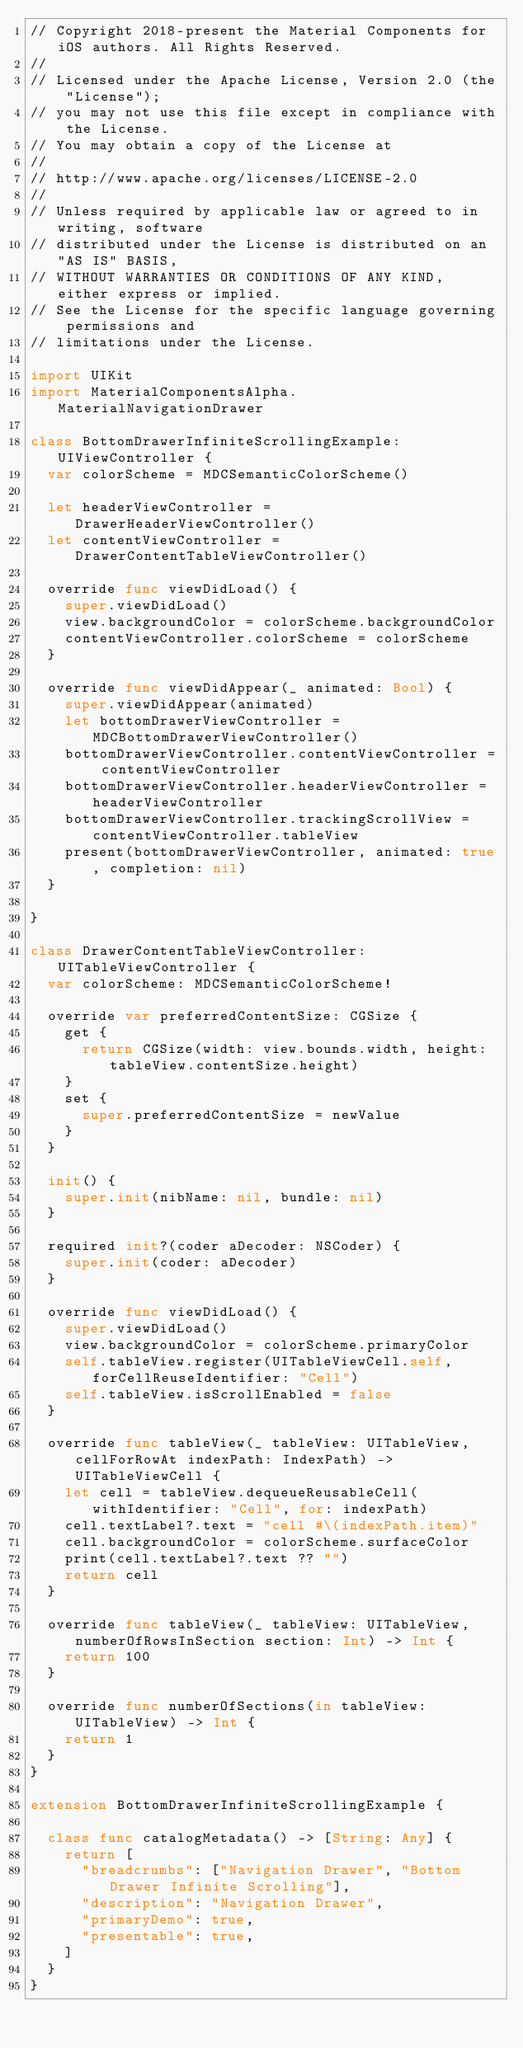Convert code to text. <code><loc_0><loc_0><loc_500><loc_500><_Swift_>// Copyright 2018-present the Material Components for iOS authors. All Rights Reserved.
//
// Licensed under the Apache License, Version 2.0 (the "License");
// you may not use this file except in compliance with the License.
// You may obtain a copy of the License at
//
// http://www.apache.org/licenses/LICENSE-2.0
//
// Unless required by applicable law or agreed to in writing, software
// distributed under the License is distributed on an "AS IS" BASIS,
// WITHOUT WARRANTIES OR CONDITIONS OF ANY KIND, either express or implied.
// See the License for the specific language governing permissions and
// limitations under the License.

import UIKit
import MaterialComponentsAlpha.MaterialNavigationDrawer

class BottomDrawerInfiniteScrollingExample: UIViewController {
  var colorScheme = MDCSemanticColorScheme()

  let headerViewController = DrawerHeaderViewController()
  let contentViewController = DrawerContentTableViewController()

  override func viewDidLoad() {
    super.viewDidLoad()
    view.backgroundColor = colorScheme.backgroundColor
    contentViewController.colorScheme = colorScheme
  }

  override func viewDidAppear(_ animated: Bool) {
    super.viewDidAppear(animated)
    let bottomDrawerViewController = MDCBottomDrawerViewController()
    bottomDrawerViewController.contentViewController = contentViewController
    bottomDrawerViewController.headerViewController = headerViewController
    bottomDrawerViewController.trackingScrollView = contentViewController.tableView
    present(bottomDrawerViewController, animated: true, completion: nil)
  }

}

class DrawerContentTableViewController: UITableViewController {
  var colorScheme: MDCSemanticColorScheme!

  override var preferredContentSize: CGSize {
    get {
      return CGSize(width: view.bounds.width, height: tableView.contentSize.height)
    }
    set {
      super.preferredContentSize = newValue
    }
  }

  init() {
    super.init(nibName: nil, bundle: nil)
  }

  required init?(coder aDecoder: NSCoder) {
    super.init(coder: aDecoder)
  }

  override func viewDidLoad() {
    super.viewDidLoad()
    view.backgroundColor = colorScheme.primaryColor
    self.tableView.register(UITableViewCell.self, forCellReuseIdentifier: "Cell")
    self.tableView.isScrollEnabled = false
  }

  override func tableView(_ tableView: UITableView, cellForRowAt indexPath: IndexPath) -> UITableViewCell {
    let cell = tableView.dequeueReusableCell(withIdentifier: "Cell", for: indexPath)
    cell.textLabel?.text = "cell #\(indexPath.item)"
    cell.backgroundColor = colorScheme.surfaceColor
    print(cell.textLabel?.text ?? "")
    return cell
  }

  override func tableView(_ tableView: UITableView, numberOfRowsInSection section: Int) -> Int {
    return 100
  }

  override func numberOfSections(in tableView: UITableView) -> Int {
    return 1
  }
}

extension BottomDrawerInfiniteScrollingExample {

  class func catalogMetadata() -> [String: Any] {
    return [
      "breadcrumbs": ["Navigation Drawer", "Bottom Drawer Infinite Scrolling"],
      "description": "Navigation Drawer",
      "primaryDemo": true,
      "presentable": true,
    ]
  }
}
</code> 